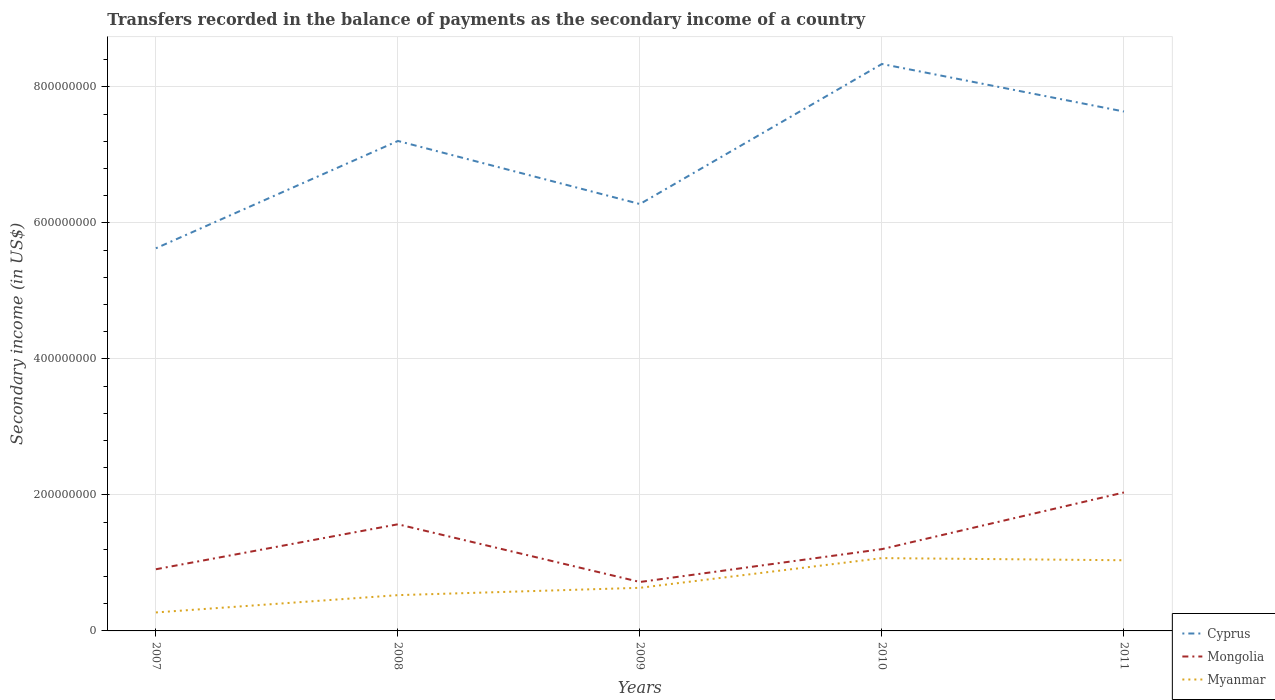Does the line corresponding to Myanmar intersect with the line corresponding to Cyprus?
Offer a very short reply. No. Is the number of lines equal to the number of legend labels?
Offer a very short reply. Yes. Across all years, what is the maximum secondary income of in Mongolia?
Offer a very short reply. 7.20e+07. In which year was the secondary income of in Myanmar maximum?
Provide a short and direct response. 2007. What is the total secondary income of in Myanmar in the graph?
Offer a terse response. 3.15e+06. What is the difference between the highest and the second highest secondary income of in Cyprus?
Give a very brief answer. 2.71e+08. Is the secondary income of in Cyprus strictly greater than the secondary income of in Mongolia over the years?
Provide a succinct answer. No. How many lines are there?
Your response must be concise. 3. How many years are there in the graph?
Make the answer very short. 5. Are the values on the major ticks of Y-axis written in scientific E-notation?
Your answer should be compact. No. Does the graph contain any zero values?
Your answer should be compact. No. Where does the legend appear in the graph?
Ensure brevity in your answer.  Bottom right. How many legend labels are there?
Offer a terse response. 3. How are the legend labels stacked?
Provide a succinct answer. Vertical. What is the title of the graph?
Offer a very short reply. Transfers recorded in the balance of payments as the secondary income of a country. Does "Iran" appear as one of the legend labels in the graph?
Your answer should be compact. No. What is the label or title of the Y-axis?
Provide a short and direct response. Secondary income (in US$). What is the Secondary income (in US$) of Cyprus in 2007?
Keep it short and to the point. 5.63e+08. What is the Secondary income (in US$) in Mongolia in 2007?
Ensure brevity in your answer.  9.07e+07. What is the Secondary income (in US$) in Myanmar in 2007?
Keep it short and to the point. 2.72e+07. What is the Secondary income (in US$) in Cyprus in 2008?
Offer a very short reply. 7.21e+08. What is the Secondary income (in US$) of Mongolia in 2008?
Keep it short and to the point. 1.57e+08. What is the Secondary income (in US$) of Myanmar in 2008?
Your response must be concise. 5.26e+07. What is the Secondary income (in US$) in Cyprus in 2009?
Offer a terse response. 6.28e+08. What is the Secondary income (in US$) in Mongolia in 2009?
Your answer should be compact. 7.20e+07. What is the Secondary income (in US$) of Myanmar in 2009?
Offer a terse response. 6.34e+07. What is the Secondary income (in US$) in Cyprus in 2010?
Give a very brief answer. 8.34e+08. What is the Secondary income (in US$) in Mongolia in 2010?
Provide a succinct answer. 1.20e+08. What is the Secondary income (in US$) in Myanmar in 2010?
Offer a very short reply. 1.07e+08. What is the Secondary income (in US$) of Cyprus in 2011?
Keep it short and to the point. 7.64e+08. What is the Secondary income (in US$) of Mongolia in 2011?
Your answer should be compact. 2.04e+08. What is the Secondary income (in US$) of Myanmar in 2011?
Offer a very short reply. 1.04e+08. Across all years, what is the maximum Secondary income (in US$) of Cyprus?
Keep it short and to the point. 8.34e+08. Across all years, what is the maximum Secondary income (in US$) of Mongolia?
Provide a short and direct response. 2.04e+08. Across all years, what is the maximum Secondary income (in US$) in Myanmar?
Your answer should be very brief. 1.07e+08. Across all years, what is the minimum Secondary income (in US$) of Cyprus?
Offer a terse response. 5.63e+08. Across all years, what is the minimum Secondary income (in US$) in Mongolia?
Your answer should be very brief. 7.20e+07. Across all years, what is the minimum Secondary income (in US$) in Myanmar?
Keep it short and to the point. 2.72e+07. What is the total Secondary income (in US$) in Cyprus in the graph?
Ensure brevity in your answer.  3.51e+09. What is the total Secondary income (in US$) in Mongolia in the graph?
Make the answer very short. 6.43e+08. What is the total Secondary income (in US$) of Myanmar in the graph?
Your response must be concise. 3.54e+08. What is the difference between the Secondary income (in US$) in Cyprus in 2007 and that in 2008?
Provide a succinct answer. -1.58e+08. What is the difference between the Secondary income (in US$) in Mongolia in 2007 and that in 2008?
Your answer should be compact. -6.61e+07. What is the difference between the Secondary income (in US$) in Myanmar in 2007 and that in 2008?
Provide a short and direct response. -2.54e+07. What is the difference between the Secondary income (in US$) in Cyprus in 2007 and that in 2009?
Keep it short and to the point. -6.51e+07. What is the difference between the Secondary income (in US$) of Mongolia in 2007 and that in 2009?
Make the answer very short. 1.87e+07. What is the difference between the Secondary income (in US$) of Myanmar in 2007 and that in 2009?
Offer a very short reply. -3.62e+07. What is the difference between the Secondary income (in US$) in Cyprus in 2007 and that in 2010?
Give a very brief answer. -2.71e+08. What is the difference between the Secondary income (in US$) in Mongolia in 2007 and that in 2010?
Ensure brevity in your answer.  -2.96e+07. What is the difference between the Secondary income (in US$) in Myanmar in 2007 and that in 2010?
Your answer should be very brief. -7.99e+07. What is the difference between the Secondary income (in US$) of Cyprus in 2007 and that in 2011?
Your answer should be compact. -2.01e+08. What is the difference between the Secondary income (in US$) of Mongolia in 2007 and that in 2011?
Provide a succinct answer. -1.13e+08. What is the difference between the Secondary income (in US$) of Myanmar in 2007 and that in 2011?
Provide a short and direct response. -7.68e+07. What is the difference between the Secondary income (in US$) in Cyprus in 2008 and that in 2009?
Ensure brevity in your answer.  9.28e+07. What is the difference between the Secondary income (in US$) of Mongolia in 2008 and that in 2009?
Offer a very short reply. 8.48e+07. What is the difference between the Secondary income (in US$) of Myanmar in 2008 and that in 2009?
Your answer should be very brief. -1.08e+07. What is the difference between the Secondary income (in US$) in Cyprus in 2008 and that in 2010?
Your answer should be very brief. -1.13e+08. What is the difference between the Secondary income (in US$) of Mongolia in 2008 and that in 2010?
Give a very brief answer. 3.65e+07. What is the difference between the Secondary income (in US$) in Myanmar in 2008 and that in 2010?
Offer a very short reply. -5.45e+07. What is the difference between the Secondary income (in US$) of Cyprus in 2008 and that in 2011?
Your answer should be compact. -4.33e+07. What is the difference between the Secondary income (in US$) in Mongolia in 2008 and that in 2011?
Give a very brief answer. -4.68e+07. What is the difference between the Secondary income (in US$) in Myanmar in 2008 and that in 2011?
Give a very brief answer. -5.13e+07. What is the difference between the Secondary income (in US$) in Cyprus in 2009 and that in 2010?
Make the answer very short. -2.06e+08. What is the difference between the Secondary income (in US$) in Mongolia in 2009 and that in 2010?
Ensure brevity in your answer.  -4.83e+07. What is the difference between the Secondary income (in US$) of Myanmar in 2009 and that in 2010?
Provide a short and direct response. -4.37e+07. What is the difference between the Secondary income (in US$) of Cyprus in 2009 and that in 2011?
Offer a terse response. -1.36e+08. What is the difference between the Secondary income (in US$) in Mongolia in 2009 and that in 2011?
Provide a succinct answer. -1.32e+08. What is the difference between the Secondary income (in US$) in Myanmar in 2009 and that in 2011?
Make the answer very short. -4.05e+07. What is the difference between the Secondary income (in US$) of Cyprus in 2010 and that in 2011?
Give a very brief answer. 6.99e+07. What is the difference between the Secondary income (in US$) in Mongolia in 2010 and that in 2011?
Provide a succinct answer. -8.33e+07. What is the difference between the Secondary income (in US$) in Myanmar in 2010 and that in 2011?
Make the answer very short. 3.15e+06. What is the difference between the Secondary income (in US$) in Cyprus in 2007 and the Secondary income (in US$) in Mongolia in 2008?
Your answer should be very brief. 4.06e+08. What is the difference between the Secondary income (in US$) in Cyprus in 2007 and the Secondary income (in US$) in Myanmar in 2008?
Ensure brevity in your answer.  5.10e+08. What is the difference between the Secondary income (in US$) in Mongolia in 2007 and the Secondary income (in US$) in Myanmar in 2008?
Your answer should be compact. 3.81e+07. What is the difference between the Secondary income (in US$) in Cyprus in 2007 and the Secondary income (in US$) in Mongolia in 2009?
Offer a very short reply. 4.91e+08. What is the difference between the Secondary income (in US$) in Cyprus in 2007 and the Secondary income (in US$) in Myanmar in 2009?
Provide a short and direct response. 4.99e+08. What is the difference between the Secondary income (in US$) of Mongolia in 2007 and the Secondary income (in US$) of Myanmar in 2009?
Provide a short and direct response. 2.73e+07. What is the difference between the Secondary income (in US$) of Cyprus in 2007 and the Secondary income (in US$) of Mongolia in 2010?
Keep it short and to the point. 4.42e+08. What is the difference between the Secondary income (in US$) in Cyprus in 2007 and the Secondary income (in US$) in Myanmar in 2010?
Provide a short and direct response. 4.56e+08. What is the difference between the Secondary income (in US$) in Mongolia in 2007 and the Secondary income (in US$) in Myanmar in 2010?
Ensure brevity in your answer.  -1.64e+07. What is the difference between the Secondary income (in US$) of Cyprus in 2007 and the Secondary income (in US$) of Mongolia in 2011?
Your response must be concise. 3.59e+08. What is the difference between the Secondary income (in US$) of Cyprus in 2007 and the Secondary income (in US$) of Myanmar in 2011?
Your response must be concise. 4.59e+08. What is the difference between the Secondary income (in US$) of Mongolia in 2007 and the Secondary income (in US$) of Myanmar in 2011?
Give a very brief answer. -1.32e+07. What is the difference between the Secondary income (in US$) in Cyprus in 2008 and the Secondary income (in US$) in Mongolia in 2009?
Offer a very short reply. 6.49e+08. What is the difference between the Secondary income (in US$) of Cyprus in 2008 and the Secondary income (in US$) of Myanmar in 2009?
Your response must be concise. 6.57e+08. What is the difference between the Secondary income (in US$) in Mongolia in 2008 and the Secondary income (in US$) in Myanmar in 2009?
Ensure brevity in your answer.  9.34e+07. What is the difference between the Secondary income (in US$) in Cyprus in 2008 and the Secondary income (in US$) in Mongolia in 2010?
Offer a very short reply. 6.00e+08. What is the difference between the Secondary income (in US$) in Cyprus in 2008 and the Secondary income (in US$) in Myanmar in 2010?
Provide a succinct answer. 6.13e+08. What is the difference between the Secondary income (in US$) of Mongolia in 2008 and the Secondary income (in US$) of Myanmar in 2010?
Give a very brief answer. 4.97e+07. What is the difference between the Secondary income (in US$) of Cyprus in 2008 and the Secondary income (in US$) of Mongolia in 2011?
Make the answer very short. 5.17e+08. What is the difference between the Secondary income (in US$) of Cyprus in 2008 and the Secondary income (in US$) of Myanmar in 2011?
Your answer should be very brief. 6.17e+08. What is the difference between the Secondary income (in US$) in Mongolia in 2008 and the Secondary income (in US$) in Myanmar in 2011?
Offer a very short reply. 5.29e+07. What is the difference between the Secondary income (in US$) in Cyprus in 2009 and the Secondary income (in US$) in Mongolia in 2010?
Your response must be concise. 5.07e+08. What is the difference between the Secondary income (in US$) in Cyprus in 2009 and the Secondary income (in US$) in Myanmar in 2010?
Your answer should be compact. 5.21e+08. What is the difference between the Secondary income (in US$) in Mongolia in 2009 and the Secondary income (in US$) in Myanmar in 2010?
Keep it short and to the point. -3.51e+07. What is the difference between the Secondary income (in US$) in Cyprus in 2009 and the Secondary income (in US$) in Mongolia in 2011?
Your response must be concise. 4.24e+08. What is the difference between the Secondary income (in US$) of Cyprus in 2009 and the Secondary income (in US$) of Myanmar in 2011?
Offer a very short reply. 5.24e+08. What is the difference between the Secondary income (in US$) of Mongolia in 2009 and the Secondary income (in US$) of Myanmar in 2011?
Your answer should be very brief. -3.20e+07. What is the difference between the Secondary income (in US$) in Cyprus in 2010 and the Secondary income (in US$) in Mongolia in 2011?
Keep it short and to the point. 6.30e+08. What is the difference between the Secondary income (in US$) in Cyprus in 2010 and the Secondary income (in US$) in Myanmar in 2011?
Make the answer very short. 7.30e+08. What is the difference between the Secondary income (in US$) in Mongolia in 2010 and the Secondary income (in US$) in Myanmar in 2011?
Keep it short and to the point. 1.64e+07. What is the average Secondary income (in US$) of Cyprus per year?
Provide a succinct answer. 7.02e+08. What is the average Secondary income (in US$) of Mongolia per year?
Your answer should be very brief. 1.29e+08. What is the average Secondary income (in US$) of Myanmar per year?
Offer a terse response. 7.08e+07. In the year 2007, what is the difference between the Secondary income (in US$) in Cyprus and Secondary income (in US$) in Mongolia?
Your answer should be very brief. 4.72e+08. In the year 2007, what is the difference between the Secondary income (in US$) of Cyprus and Secondary income (in US$) of Myanmar?
Offer a very short reply. 5.36e+08. In the year 2007, what is the difference between the Secondary income (in US$) in Mongolia and Secondary income (in US$) in Myanmar?
Make the answer very short. 6.35e+07. In the year 2008, what is the difference between the Secondary income (in US$) of Cyprus and Secondary income (in US$) of Mongolia?
Your answer should be compact. 5.64e+08. In the year 2008, what is the difference between the Secondary income (in US$) in Cyprus and Secondary income (in US$) in Myanmar?
Make the answer very short. 6.68e+08. In the year 2008, what is the difference between the Secondary income (in US$) of Mongolia and Secondary income (in US$) of Myanmar?
Ensure brevity in your answer.  1.04e+08. In the year 2009, what is the difference between the Secondary income (in US$) in Cyprus and Secondary income (in US$) in Mongolia?
Offer a terse response. 5.56e+08. In the year 2009, what is the difference between the Secondary income (in US$) of Cyprus and Secondary income (in US$) of Myanmar?
Offer a very short reply. 5.64e+08. In the year 2009, what is the difference between the Secondary income (in US$) of Mongolia and Secondary income (in US$) of Myanmar?
Keep it short and to the point. 8.56e+06. In the year 2010, what is the difference between the Secondary income (in US$) in Cyprus and Secondary income (in US$) in Mongolia?
Your response must be concise. 7.13e+08. In the year 2010, what is the difference between the Secondary income (in US$) of Cyprus and Secondary income (in US$) of Myanmar?
Give a very brief answer. 7.27e+08. In the year 2010, what is the difference between the Secondary income (in US$) in Mongolia and Secondary income (in US$) in Myanmar?
Give a very brief answer. 1.32e+07. In the year 2011, what is the difference between the Secondary income (in US$) of Cyprus and Secondary income (in US$) of Mongolia?
Give a very brief answer. 5.60e+08. In the year 2011, what is the difference between the Secondary income (in US$) in Cyprus and Secondary income (in US$) in Myanmar?
Offer a terse response. 6.60e+08. In the year 2011, what is the difference between the Secondary income (in US$) in Mongolia and Secondary income (in US$) in Myanmar?
Your answer should be compact. 9.97e+07. What is the ratio of the Secondary income (in US$) in Cyprus in 2007 to that in 2008?
Your response must be concise. 0.78. What is the ratio of the Secondary income (in US$) in Mongolia in 2007 to that in 2008?
Provide a succinct answer. 0.58. What is the ratio of the Secondary income (in US$) of Myanmar in 2007 to that in 2008?
Your answer should be compact. 0.52. What is the ratio of the Secondary income (in US$) in Cyprus in 2007 to that in 2009?
Keep it short and to the point. 0.9. What is the ratio of the Secondary income (in US$) in Mongolia in 2007 to that in 2009?
Keep it short and to the point. 1.26. What is the ratio of the Secondary income (in US$) of Myanmar in 2007 to that in 2009?
Offer a terse response. 0.43. What is the ratio of the Secondary income (in US$) in Cyprus in 2007 to that in 2010?
Your answer should be compact. 0.67. What is the ratio of the Secondary income (in US$) of Mongolia in 2007 to that in 2010?
Your answer should be compact. 0.75. What is the ratio of the Secondary income (in US$) of Myanmar in 2007 to that in 2010?
Offer a terse response. 0.25. What is the ratio of the Secondary income (in US$) in Cyprus in 2007 to that in 2011?
Make the answer very short. 0.74. What is the ratio of the Secondary income (in US$) in Mongolia in 2007 to that in 2011?
Keep it short and to the point. 0.45. What is the ratio of the Secondary income (in US$) of Myanmar in 2007 to that in 2011?
Provide a short and direct response. 0.26. What is the ratio of the Secondary income (in US$) in Cyprus in 2008 to that in 2009?
Your answer should be very brief. 1.15. What is the ratio of the Secondary income (in US$) in Mongolia in 2008 to that in 2009?
Offer a terse response. 2.18. What is the ratio of the Secondary income (in US$) of Myanmar in 2008 to that in 2009?
Ensure brevity in your answer.  0.83. What is the ratio of the Secondary income (in US$) in Cyprus in 2008 to that in 2010?
Offer a terse response. 0.86. What is the ratio of the Secondary income (in US$) in Mongolia in 2008 to that in 2010?
Provide a short and direct response. 1.3. What is the ratio of the Secondary income (in US$) in Myanmar in 2008 to that in 2010?
Ensure brevity in your answer.  0.49. What is the ratio of the Secondary income (in US$) in Cyprus in 2008 to that in 2011?
Your answer should be compact. 0.94. What is the ratio of the Secondary income (in US$) of Mongolia in 2008 to that in 2011?
Your answer should be compact. 0.77. What is the ratio of the Secondary income (in US$) of Myanmar in 2008 to that in 2011?
Offer a terse response. 0.51. What is the ratio of the Secondary income (in US$) in Cyprus in 2009 to that in 2010?
Provide a short and direct response. 0.75. What is the ratio of the Secondary income (in US$) in Mongolia in 2009 to that in 2010?
Offer a terse response. 0.6. What is the ratio of the Secondary income (in US$) in Myanmar in 2009 to that in 2010?
Ensure brevity in your answer.  0.59. What is the ratio of the Secondary income (in US$) in Cyprus in 2009 to that in 2011?
Your response must be concise. 0.82. What is the ratio of the Secondary income (in US$) of Mongolia in 2009 to that in 2011?
Make the answer very short. 0.35. What is the ratio of the Secondary income (in US$) of Myanmar in 2009 to that in 2011?
Make the answer very short. 0.61. What is the ratio of the Secondary income (in US$) in Cyprus in 2010 to that in 2011?
Ensure brevity in your answer.  1.09. What is the ratio of the Secondary income (in US$) of Mongolia in 2010 to that in 2011?
Offer a terse response. 0.59. What is the ratio of the Secondary income (in US$) in Myanmar in 2010 to that in 2011?
Offer a very short reply. 1.03. What is the difference between the highest and the second highest Secondary income (in US$) of Cyprus?
Provide a succinct answer. 6.99e+07. What is the difference between the highest and the second highest Secondary income (in US$) in Mongolia?
Ensure brevity in your answer.  4.68e+07. What is the difference between the highest and the second highest Secondary income (in US$) of Myanmar?
Your answer should be very brief. 3.15e+06. What is the difference between the highest and the lowest Secondary income (in US$) in Cyprus?
Make the answer very short. 2.71e+08. What is the difference between the highest and the lowest Secondary income (in US$) of Mongolia?
Provide a short and direct response. 1.32e+08. What is the difference between the highest and the lowest Secondary income (in US$) of Myanmar?
Your response must be concise. 7.99e+07. 